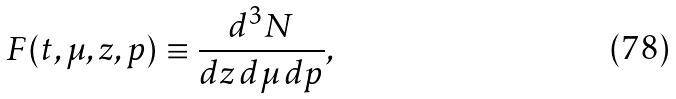<formula> <loc_0><loc_0><loc_500><loc_500>F ( t , \mu , z , p ) \equiv \frac { d ^ { 3 } N } { d z \, d \mu \, d p } ,</formula> 